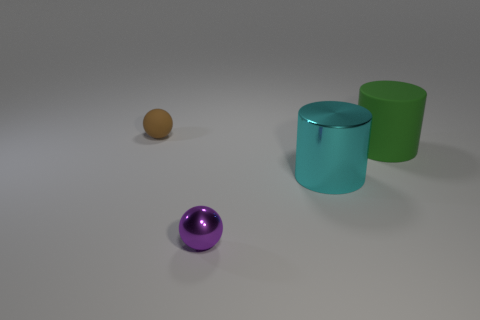What number of things are either balls or large cyan metal objects?
Make the answer very short. 3. Is there a small green thing?
Your answer should be compact. No. What is the material of the cylinder on the right side of the large cyan metal cylinder in front of the large green cylinder behind the large metallic thing?
Provide a short and direct response. Rubber. Are there fewer tiny brown objects that are in front of the large rubber cylinder than tiny red rubber balls?
Your response must be concise. No. There is another thing that is the same size as the cyan shiny thing; what material is it?
Provide a succinct answer. Rubber. There is a object that is both in front of the large green cylinder and behind the small purple sphere; what is its size?
Your response must be concise. Large. There is another thing that is the same shape as the large cyan metallic object; what size is it?
Offer a very short reply. Large. How many objects are cyan metallic cylinders or big cylinders to the left of the green rubber thing?
Provide a succinct answer. 1. What shape is the small brown rubber thing?
Your response must be concise. Sphere. The shiny object that is on the left side of the metal object to the right of the tiny purple ball is what shape?
Your answer should be very brief. Sphere. 